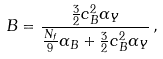Convert formula to latex. <formula><loc_0><loc_0><loc_500><loc_500>B = \frac { \frac { 3 } { 2 } c _ { B } ^ { 2 } \alpha _ { Y } } { \frac { N _ { f } } { 9 } \alpha _ { B } + \frac { 3 } { 2 } c _ { B } ^ { 2 } \alpha _ { Y } } \, ,</formula> 